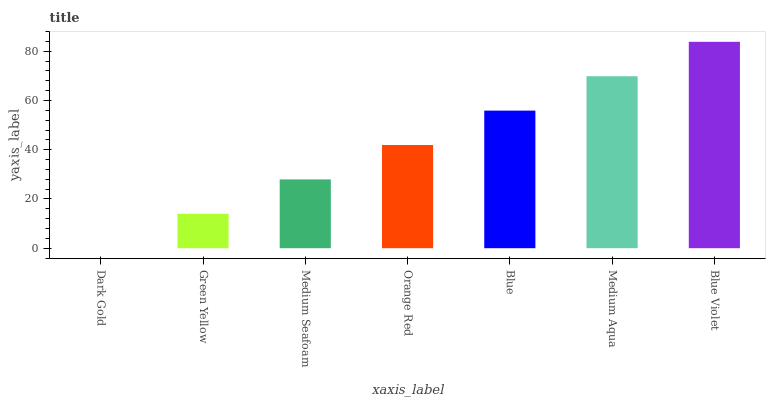Is Dark Gold the minimum?
Answer yes or no. Yes. Is Blue Violet the maximum?
Answer yes or no. Yes. Is Green Yellow the minimum?
Answer yes or no. No. Is Green Yellow the maximum?
Answer yes or no. No. Is Green Yellow greater than Dark Gold?
Answer yes or no. Yes. Is Dark Gold less than Green Yellow?
Answer yes or no. Yes. Is Dark Gold greater than Green Yellow?
Answer yes or no. No. Is Green Yellow less than Dark Gold?
Answer yes or no. No. Is Orange Red the high median?
Answer yes or no. Yes. Is Orange Red the low median?
Answer yes or no. Yes. Is Green Yellow the high median?
Answer yes or no. No. Is Dark Gold the low median?
Answer yes or no. No. 